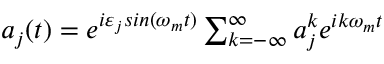<formula> <loc_0><loc_0><loc_500><loc_500>\begin{array} { r } { a _ { j } ( t ) = e ^ { i \varepsilon _ { j } \sin ( \omega _ { m } t ) } \sum _ { k = - \infty } ^ { \infty } a _ { j } ^ { k } e ^ { i k \omega _ { m } t } } \end{array}</formula> 